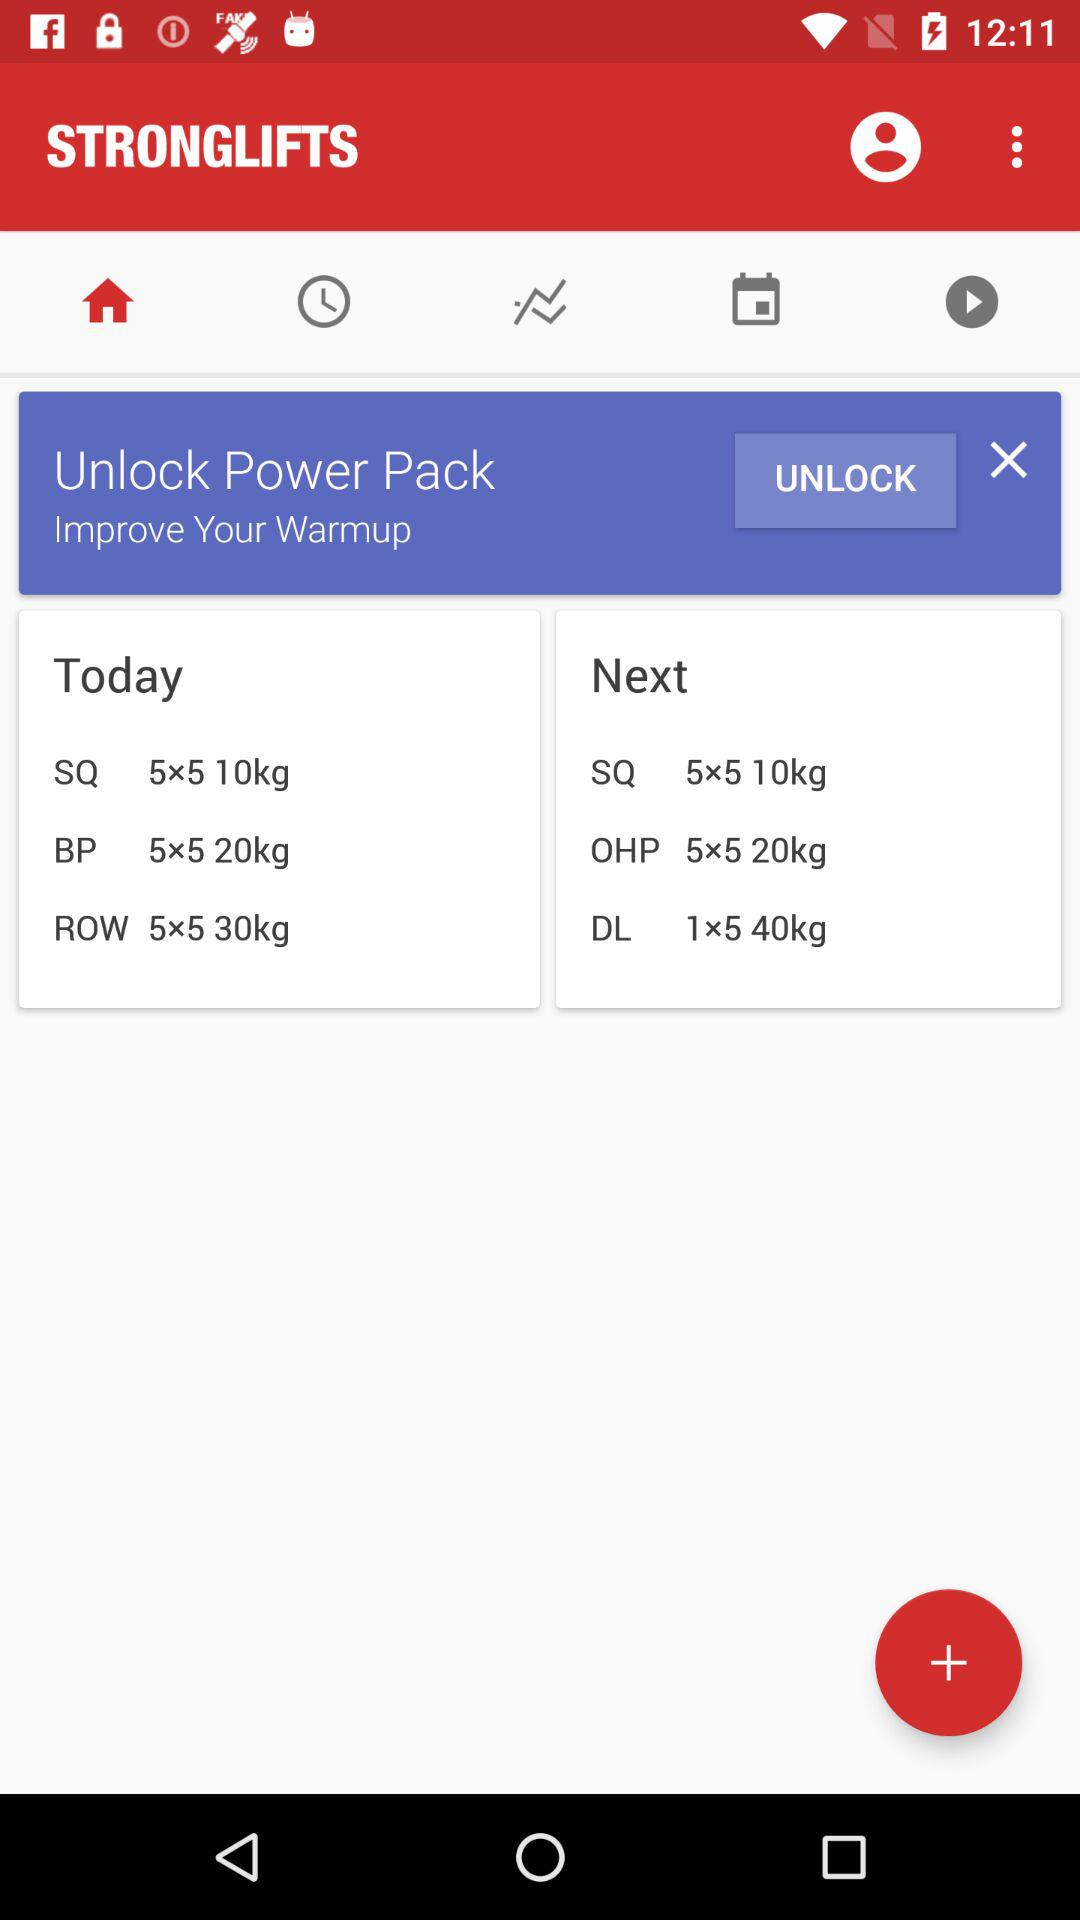Which tab am I on? You are on the "Home" tab. 